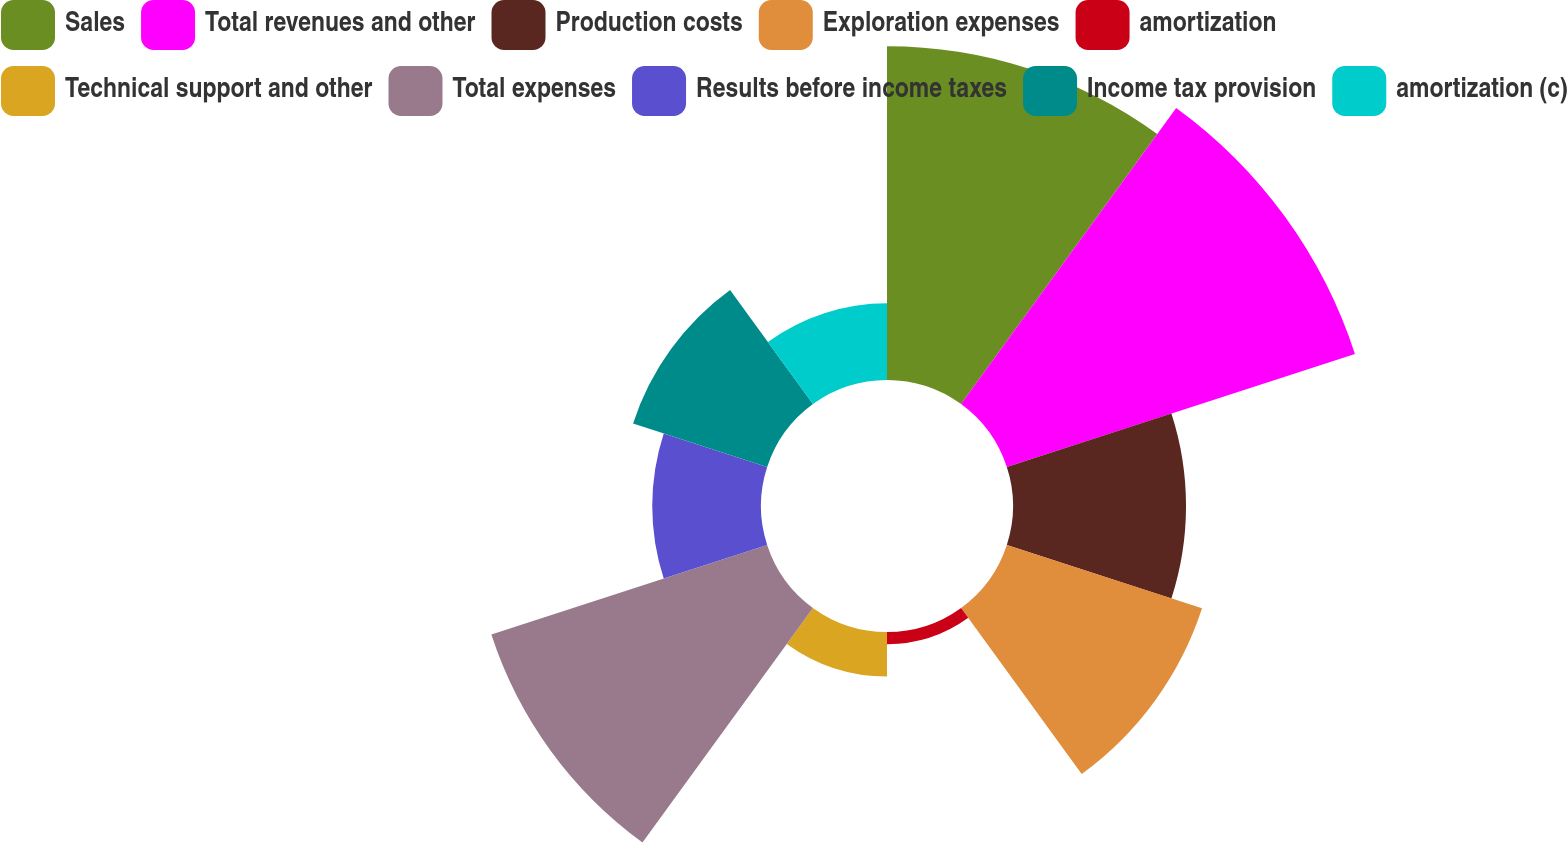Convert chart. <chart><loc_0><loc_0><loc_500><loc_500><pie_chart><fcel>Sales<fcel>Total revenues and other<fcel>Production costs<fcel>Exploration expenses<fcel>amortization<fcel>Technical support and other<fcel>Total expenses<fcel>Results before income taxes<fcel>Income tax provision<fcel>amortization (c)<nl><fcel>19.06%<fcel>20.9%<fcel>9.88%<fcel>11.72%<fcel>0.7%<fcel>2.54%<fcel>16.56%<fcel>6.21%<fcel>8.05%<fcel>4.38%<nl></chart> 